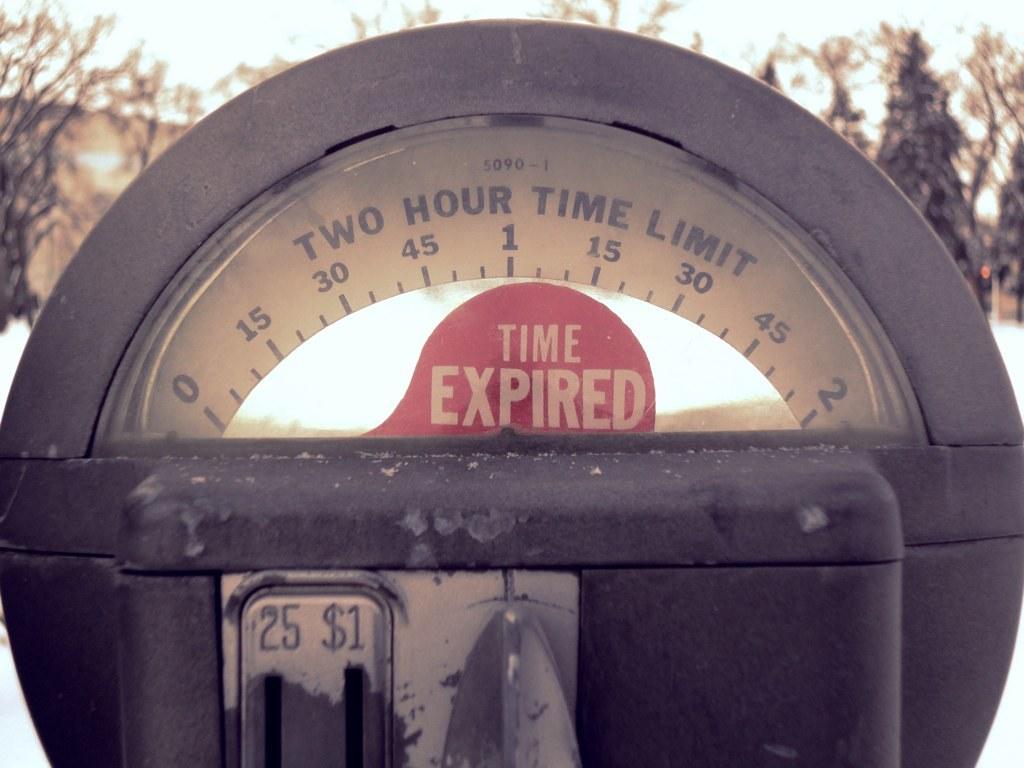Did they use the whole 2 hours?
Keep it short and to the point. Yes. What kind of coins does this take?
Your response must be concise. Quarters. 